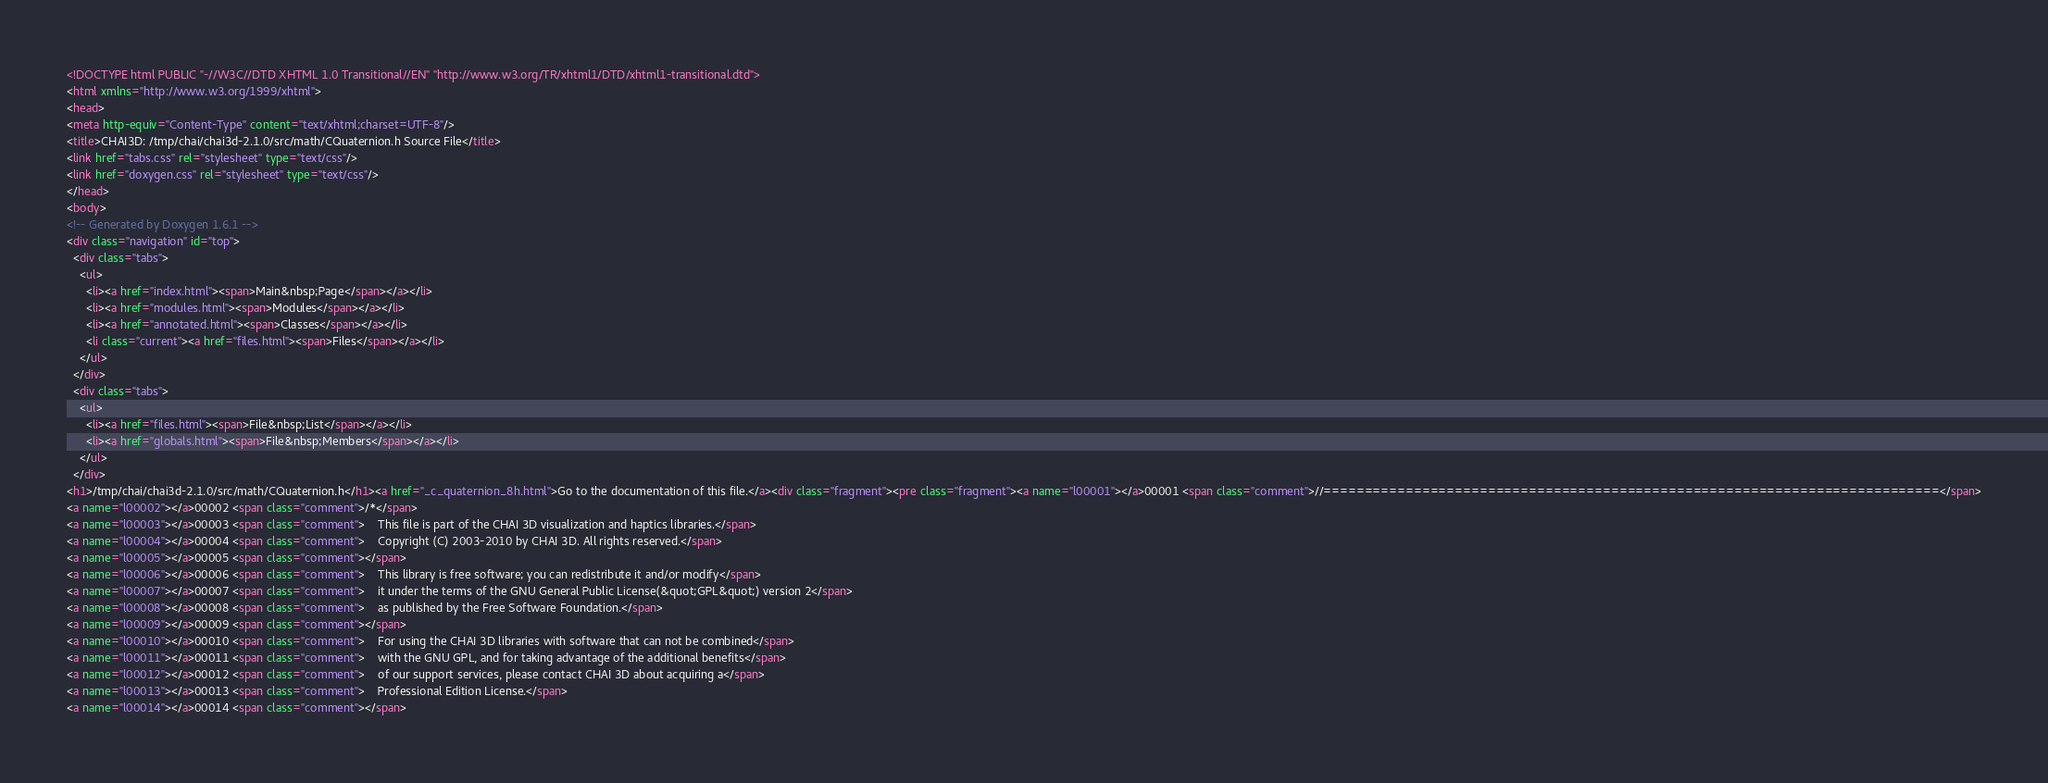Convert code to text. <code><loc_0><loc_0><loc_500><loc_500><_HTML_><!DOCTYPE html PUBLIC "-//W3C//DTD XHTML 1.0 Transitional//EN" "http://www.w3.org/TR/xhtml1/DTD/xhtml1-transitional.dtd">
<html xmlns="http://www.w3.org/1999/xhtml">
<head>
<meta http-equiv="Content-Type" content="text/xhtml;charset=UTF-8"/>
<title>CHAI3D: /tmp/chai/chai3d-2.1.0/src/math/CQuaternion.h Source File</title>
<link href="tabs.css" rel="stylesheet" type="text/css"/>
<link href="doxygen.css" rel="stylesheet" type="text/css"/>
</head>
<body>
<!-- Generated by Doxygen 1.6.1 -->
<div class="navigation" id="top">
  <div class="tabs">
    <ul>
      <li><a href="index.html"><span>Main&nbsp;Page</span></a></li>
      <li><a href="modules.html"><span>Modules</span></a></li>
      <li><a href="annotated.html"><span>Classes</span></a></li>
      <li class="current"><a href="files.html"><span>Files</span></a></li>
    </ul>
  </div>
  <div class="tabs">
    <ul>
      <li><a href="files.html"><span>File&nbsp;List</span></a></li>
      <li><a href="globals.html"><span>File&nbsp;Members</span></a></li>
    </ul>
  </div>
<h1>/tmp/chai/chai3d-2.1.0/src/math/CQuaternion.h</h1><a href="_c_quaternion_8h.html">Go to the documentation of this file.</a><div class="fragment"><pre class="fragment"><a name="l00001"></a>00001 <span class="comment">//===========================================================================</span>
<a name="l00002"></a>00002 <span class="comment">/*</span>
<a name="l00003"></a>00003 <span class="comment">    This file is part of the CHAI 3D visualization and haptics libraries.</span>
<a name="l00004"></a>00004 <span class="comment">    Copyright (C) 2003-2010 by CHAI 3D. All rights reserved.</span>
<a name="l00005"></a>00005 <span class="comment"></span>
<a name="l00006"></a>00006 <span class="comment">    This library is free software; you can redistribute it and/or modify</span>
<a name="l00007"></a>00007 <span class="comment">    it under the terms of the GNU General Public License(&quot;GPL&quot;) version 2</span>
<a name="l00008"></a>00008 <span class="comment">    as published by the Free Software Foundation.</span>
<a name="l00009"></a>00009 <span class="comment"></span>
<a name="l00010"></a>00010 <span class="comment">    For using the CHAI 3D libraries with software that can not be combined</span>
<a name="l00011"></a>00011 <span class="comment">    with the GNU GPL, and for taking advantage of the additional benefits</span>
<a name="l00012"></a>00012 <span class="comment">    of our support services, please contact CHAI 3D about acquiring a</span>
<a name="l00013"></a>00013 <span class="comment">    Professional Edition License.</span>
<a name="l00014"></a>00014 <span class="comment"></span></code> 